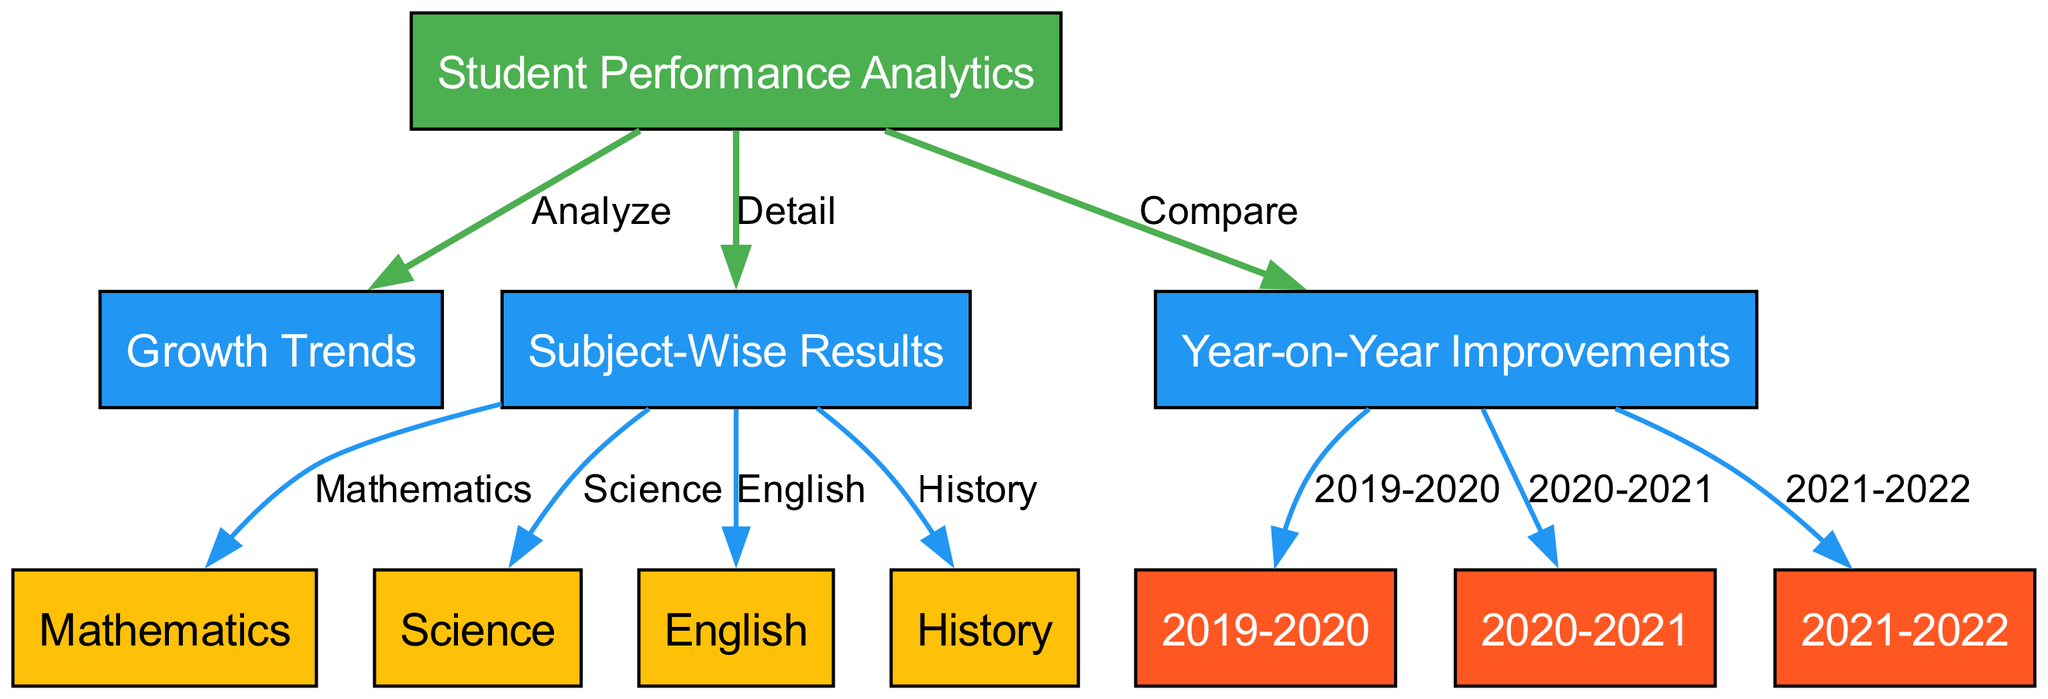What is the main focus of the diagram? The central node, labeled "Student Performance Analytics," indicates the main focus of the diagram, which is on analyzing student performance.
Answer: Student Performance Analytics How many subject-wise results are shown in the diagram? The edges from the "Subject-Wise Results" node connect to four subject nodes (Mathematics, Science, English, History), indicating a total of four subjects.
Answer: Four What is the relationship between "Student Performance Analytics" and "Growth Trends"? The edge labeled "Analyze" connects the "Student Performance Analytics" node to the "Growth Trends" node, indicating that growth trends are to be analyzed in relation to student performance.
Answer: Analyze Which years are represented under the "Year-on-Year Improvements"? The "Year-on-Year Improvements" node connects to three nodes representing the years: 2019-2020, 2020-2021, and 2021-2022. This shows explicit representation for these three years.
Answer: 2019-2020, 2020-2021, 2021-2022 What type of relationship exists between "Year-on-Year Improvements" and "2020-2021"? The label "2020-2021" is an edge from the "Year-on-Year Improvements," meaning it is one of the years being compared for improvement over previous years, specifying a comparison relationship.
Answer: Compare How many total nodes are present in the diagram? By counting all the nodes, which include the main performance node, growth trends, subject-wise results, year-on-year improvement years, and subjects, we find there are 11 nodes in total.
Answer: Eleven Which subject had the node connecting directly to the "Subject-Wise Results"? Among the edges leading from "Subject-Wise Results," the node labeled "Mathematics" indicates it is one of the subjects directly connected.
Answer: Mathematics What kind of analysis is indicated in the relationship between "Student Performance Analytics" and "Year-on-Year Improvements"? The edge label "Compare" denotes that there is a comparative analysis indicated between student performances year by year.
Answer: Compare In which direction do the edges mainly flow from the "Student Performance Analytics"? The edges flow outward from "Student Performance Analytics" to the "Growth Trends," "Subject-Wise Results," and "Year-on-Year Improvements," indicating that this node is a source of information.
Answer: Outward 